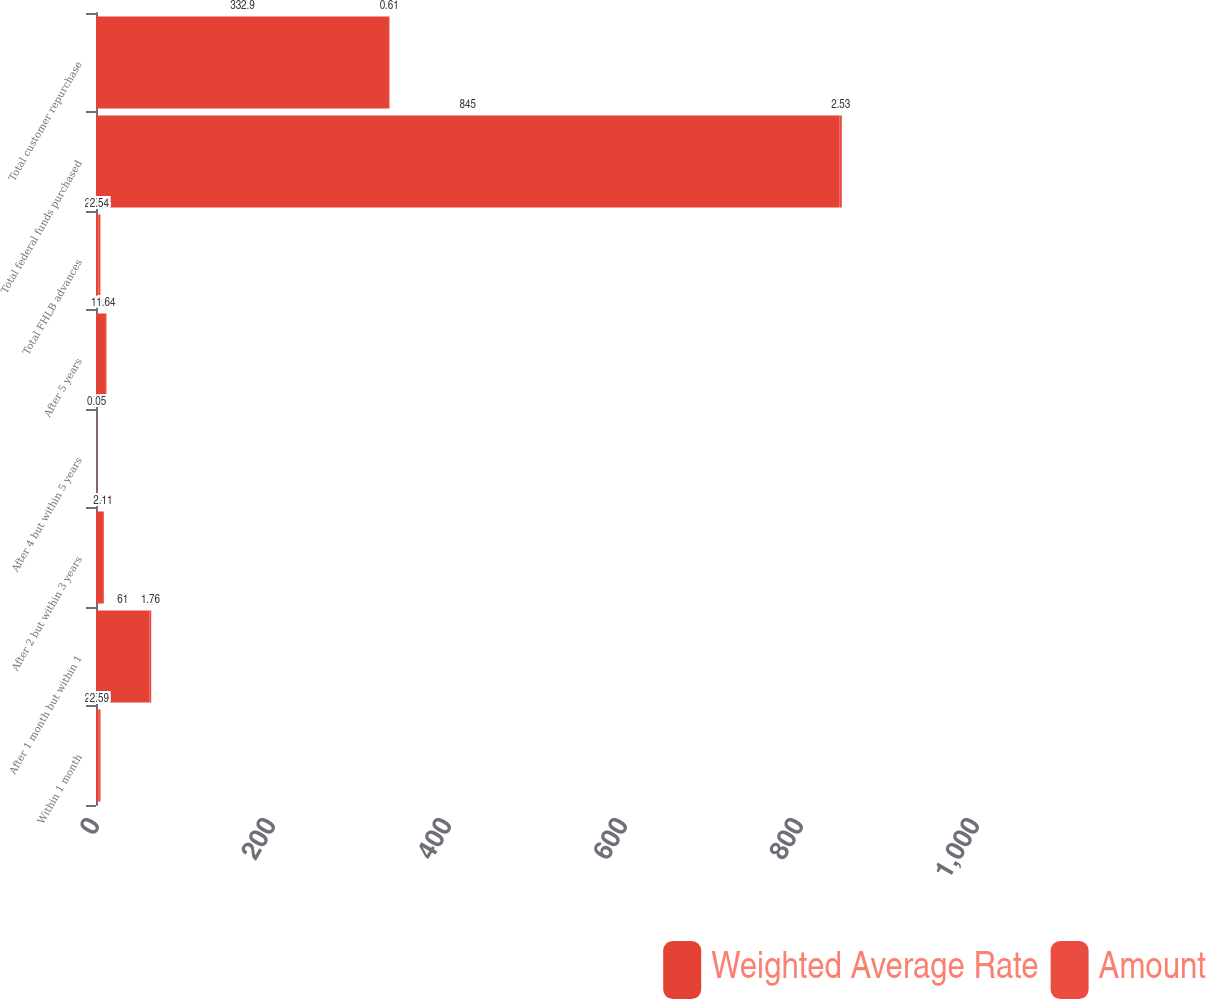Convert chart. <chart><loc_0><loc_0><loc_500><loc_500><stacked_bar_chart><ecel><fcel>Within 1 month<fcel>After 1 month but within 1<fcel>After 2 but within 3 years<fcel>After 4 but within 5 years<fcel>After 5 years<fcel>Total FHLB advances<fcel>Total federal funds purchased<fcel>Total customer repurchase<nl><fcel>Weighted Average Rate<fcel>2.535<fcel>61<fcel>6.8<fcel>0.6<fcel>10.3<fcel>2.535<fcel>845<fcel>332.9<nl><fcel>Amount<fcel>2.59<fcel>1.76<fcel>2.11<fcel>0.05<fcel>1.64<fcel>2.54<fcel>2.53<fcel>0.61<nl></chart> 